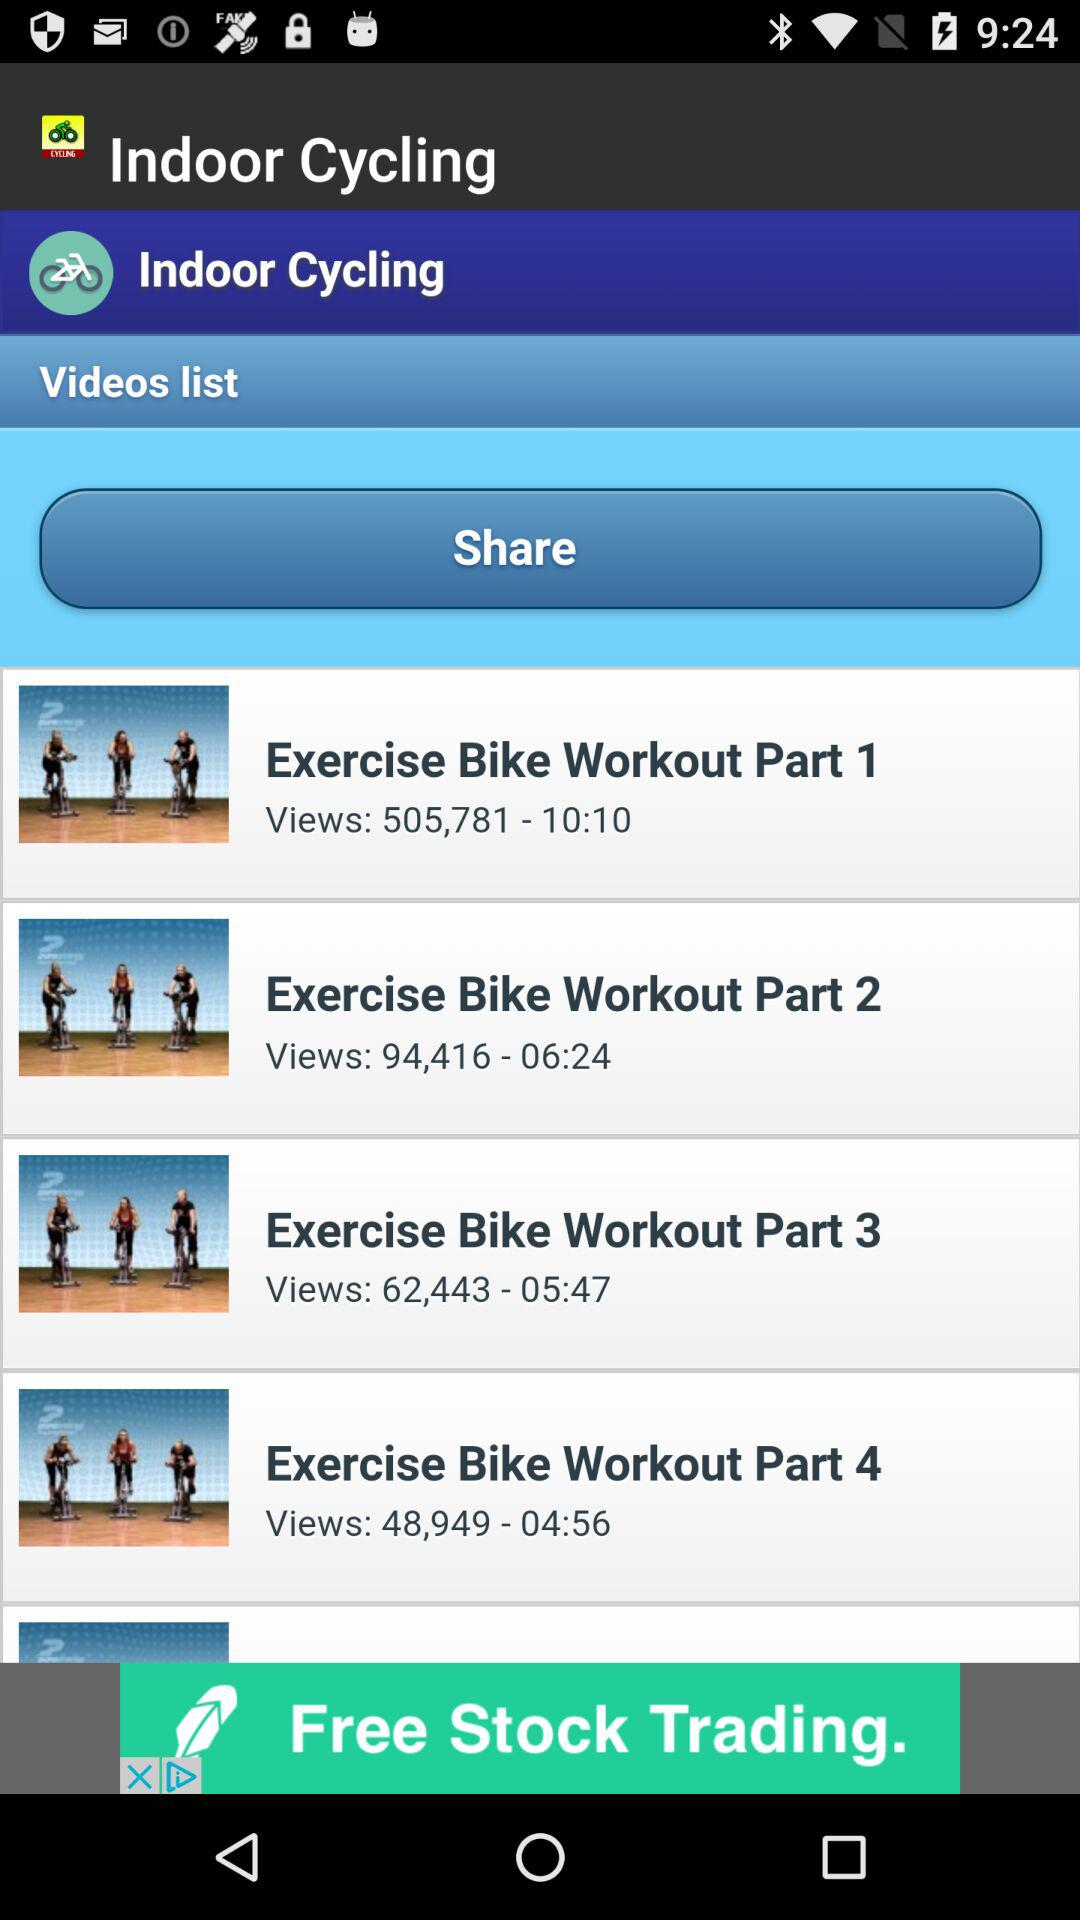Which are the different videos? The different videos are "Exercise Bike Workout Part 1", "Exercise Bike Workout Part 2", "Exercise Bike Workout Part 3" and "Exercise Bike Workout Part 4". 